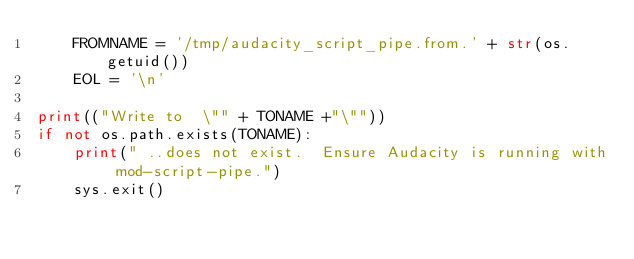Convert code to text. <code><loc_0><loc_0><loc_500><loc_500><_Python_>    FROMNAME = '/tmp/audacity_script_pipe.from.' + str(os.getuid())
    EOL = '\n'

print(("Write to  \"" + TONAME +"\""))
if not os.path.exists(TONAME):
    print(" ..does not exist.  Ensure Audacity is running with mod-script-pipe.")
    sys.exit()
</code> 